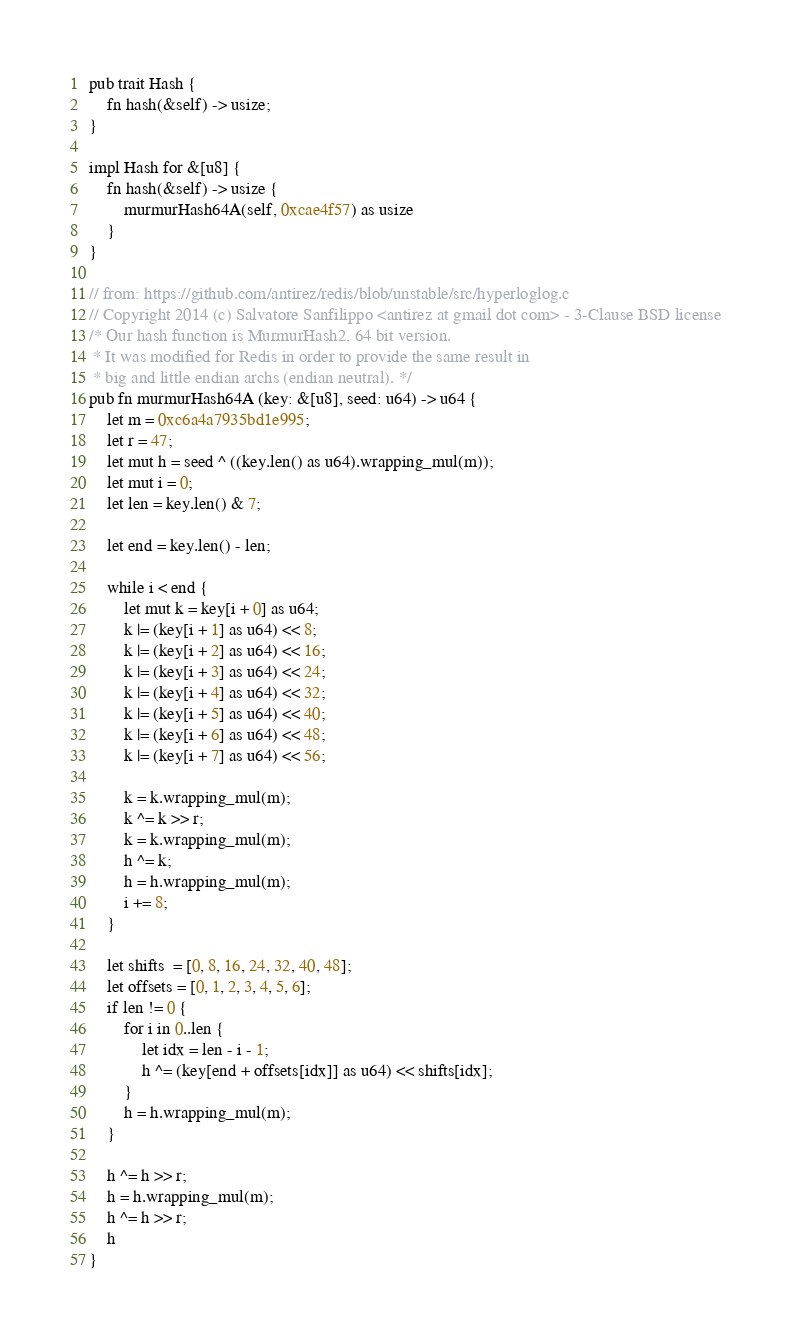Convert code to text. <code><loc_0><loc_0><loc_500><loc_500><_Rust_>pub trait Hash {
    fn hash(&self) -> usize;
}

impl Hash for &[u8] {
    fn hash(&self) -> usize {
        murmurHash64A(self, 0xcae4f57) as usize
    }
}

// from: https://github.com/antirez/redis/blob/unstable/src/hyperloglog.c
// Copyright 2014 (c) Salvatore Sanfilippo <antirez at gmail dot com> - 3-Clause BSD license
/* Our hash function is MurmurHash2, 64 bit version.
 * It was modified for Redis in order to provide the same result in
 * big and little endian archs (endian neutral). */
pub fn murmurHash64A (key: &[u8], seed: u64) -> u64 {
    let m = 0xc6a4a7935bd1e995;
    let r = 47;
    let mut h = seed ^ ((key.len() as u64).wrapping_mul(m));
    let mut i = 0;
    let len = key.len() & 7;

    let end = key.len() - len;

    while i < end {
        let mut k = key[i + 0] as u64;
        k |= (key[i + 1] as u64) << 8;
        k |= (key[i + 2] as u64) << 16;
        k |= (key[i + 3] as u64) << 24;
        k |= (key[i + 4] as u64) << 32;
        k |= (key[i + 5] as u64) << 40;
        k |= (key[i + 6] as u64) << 48;
        k |= (key[i + 7] as u64) << 56;

        k = k.wrapping_mul(m);
        k ^= k >> r;
        k = k.wrapping_mul(m);
        h ^= k;
        h = h.wrapping_mul(m);
        i += 8;
    }

    let shifts  = [0, 8, 16, 24, 32, 40, 48];
    let offsets = [0, 1, 2, 3, 4, 5, 6];
    if len != 0 {
        for i in 0..len {
            let idx = len - i - 1;
            h ^= (key[end + offsets[idx]] as u64) << shifts[idx];
        }
        h = h.wrapping_mul(m);
    }

    h ^= h >> r;
    h = h.wrapping_mul(m);
    h ^= h >> r;
    h
}
</code> 